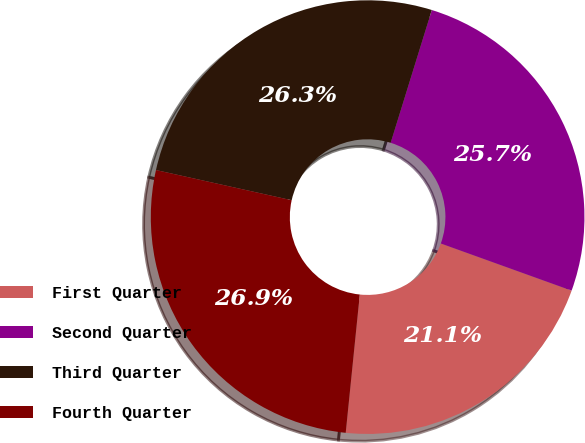<chart> <loc_0><loc_0><loc_500><loc_500><pie_chart><fcel>First Quarter<fcel>Second Quarter<fcel>Third Quarter<fcel>Fourth Quarter<nl><fcel>21.11%<fcel>25.72%<fcel>26.3%<fcel>26.87%<nl></chart> 